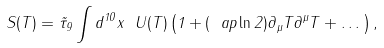<formula> <loc_0><loc_0><loc_500><loc_500>S ( T ) = \tilde { \tau } _ { 9 } \int d ^ { 1 0 } x \ U ( T ) \left ( 1 + ( \ a p \ln 2 ) \partial _ { \mu } T \partial ^ { \mu } T + \dots \right ) ,</formula> 